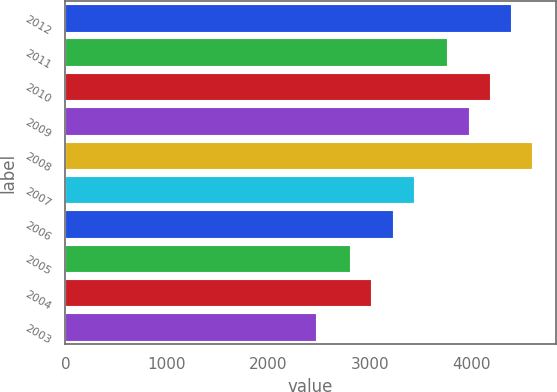<chart> <loc_0><loc_0><loc_500><loc_500><bar_chart><fcel>2012<fcel>2011<fcel>2010<fcel>2009<fcel>2008<fcel>2007<fcel>2006<fcel>2005<fcel>2004<fcel>2003<nl><fcel>4387.4<fcel>3758<fcel>4177.6<fcel>3967.8<fcel>4597.2<fcel>3430.4<fcel>3220.6<fcel>2801<fcel>3010.8<fcel>2466<nl></chart> 